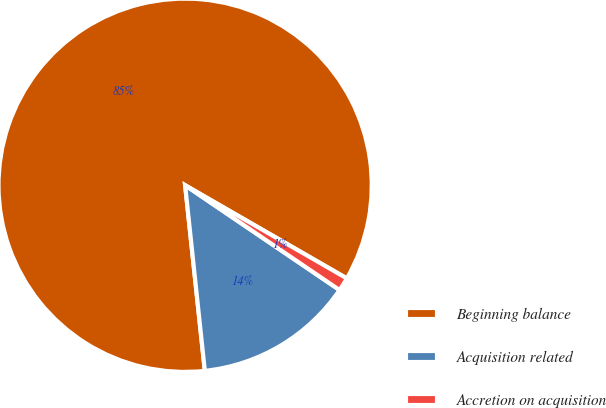<chart> <loc_0><loc_0><loc_500><loc_500><pie_chart><fcel>Beginning balance<fcel>Acquisition related<fcel>Accretion on acquisition<nl><fcel>85.0%<fcel>13.83%<fcel>1.17%<nl></chart> 